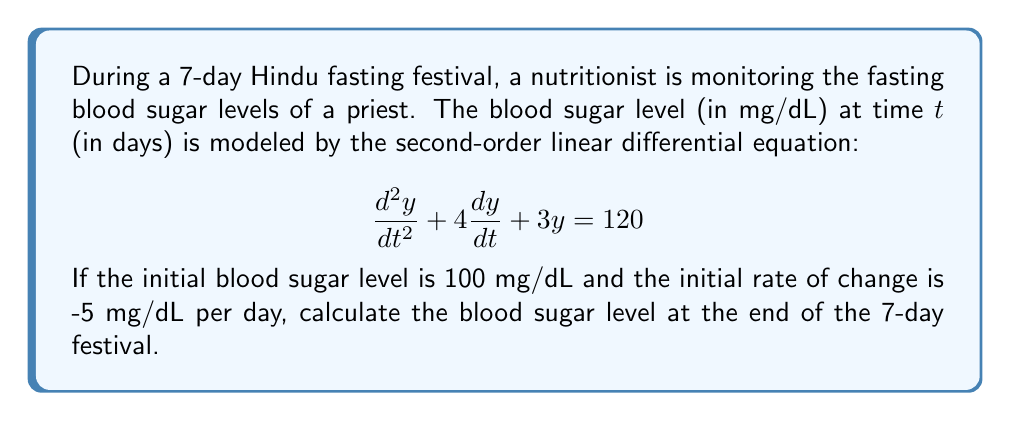Give your solution to this math problem. To solve this problem, we need to follow these steps:

1) The general solution to this second-order linear differential equation is:

   $y = c_1e^{-t} + c_2e^{-3t} + 40$

2) We need to find $c_1$ and $c_2$ using the initial conditions:
   
   At $t=0$, $y(0) = 100$ and $y'(0) = -5$

3) Using $y(0) = 100$:
   
   $100 = c_1 + c_2 + 40$
   $c_1 + c_2 = 60$ ... (Equation 1)

4) Now, let's use $y'(0) = -5$:
   
   $y' = -c_1e^{-t} - 3c_2e^{-3t}$
   
   At $t=0$: $-5 = -c_1 - 3c_2$ ... (Equation 2)

5) Solving Equations 1 and 2 simultaneously:
   
   From Equation 2: $c_1 = 5 - 3c_2$
   
   Substituting into Equation 1:
   $(5 - 3c_2) + c_2 = 60$
   $5 - 2c_2 = 60$
   $-2c_2 = 55$
   $c_2 = -27.5$

   Then, $c_1 = 5 - 3(-27.5) = 87.5$

6) Now we have the particular solution:

   $y = 87.5e^{-t} - 27.5e^{-3t} + 40$

7) To find the blood sugar level at $t=7$ (end of the 7-day festival):

   $y(7) = 87.5e^{-7} - 27.5e^{-21} + 40$

8) Calculating this:

   $y(7) \approx 87.5(0.0009) - 27.5(7.583 \times 10^{-10}) + 40$
         $\approx 0.07875 - 0.00000002 + 40$
         $\approx 40.08$ mg/dL
Answer: The blood sugar level at the end of the 7-day festival is approximately 40.08 mg/dL. 